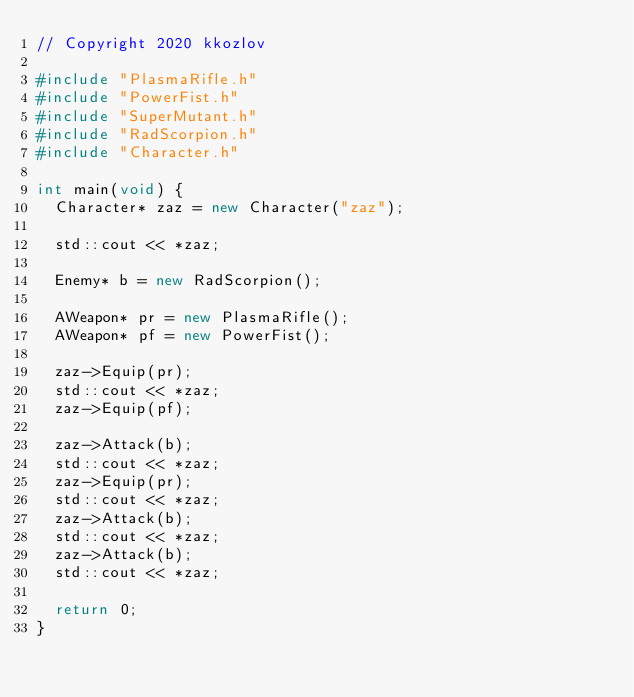Convert code to text. <code><loc_0><loc_0><loc_500><loc_500><_C++_>// Copyright 2020 kkozlov

#include "PlasmaRifle.h"
#include "PowerFist.h"
#include "SuperMutant.h"
#include "RadScorpion.h"
#include "Character.h"

int main(void) {
  Character* zaz = new Character("zaz");

  std::cout << *zaz;

  Enemy* b = new RadScorpion();

  AWeapon* pr = new PlasmaRifle();
  AWeapon* pf = new PowerFist();

  zaz->Equip(pr);
  std::cout << *zaz;
  zaz->Equip(pf);

  zaz->Attack(b);
  std::cout << *zaz;
  zaz->Equip(pr);
  std::cout << *zaz;
  zaz->Attack(b);
  std::cout << *zaz;
  zaz->Attack(b);
  std::cout << *zaz;

  return 0;
}
</code> 